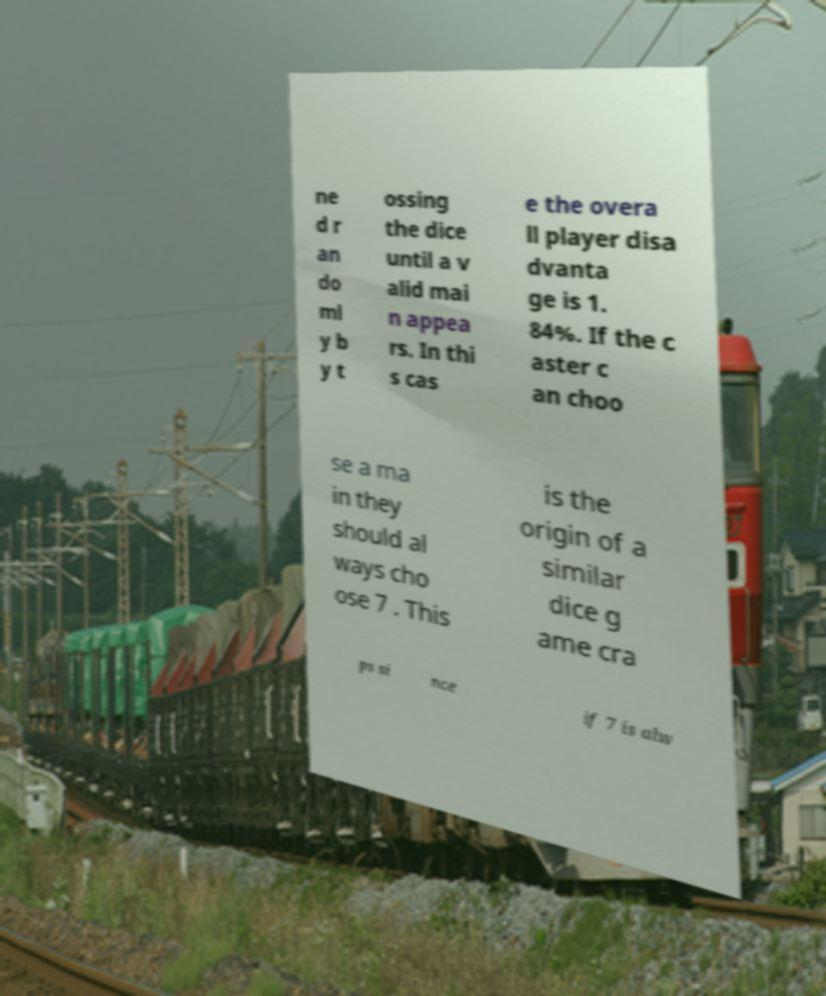Can you accurately transcribe the text from the provided image for me? ne d r an do ml y b y t ossing the dice until a v alid mai n appea rs. In thi s cas e the overa ll player disa dvanta ge is 1. 84%. If the c aster c an choo se a ma in they should al ways cho ose 7 . This is the origin of a similar dice g ame cra ps si nce if 7 is alw 